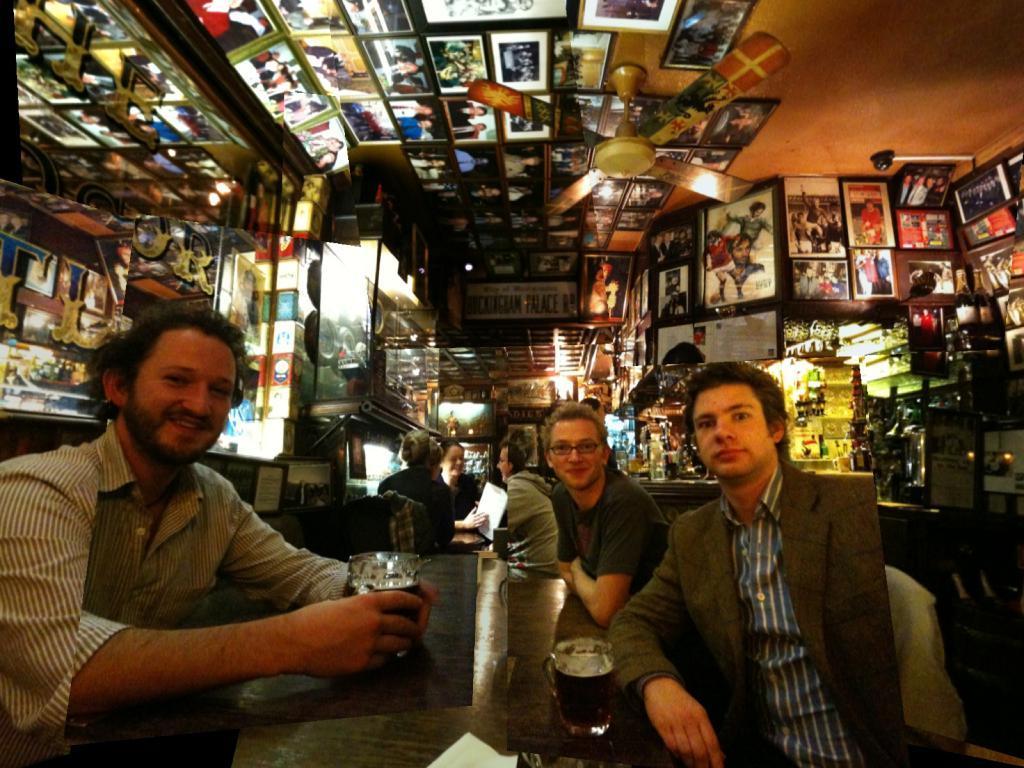How would you summarize this image in a sentence or two? In the center of the image we can see a few people are sitting. Among them, we can see two persons are holding some objects. And we can see one table. On the table, we can see some objects. In the background there is a wall, fan, photo frames, lights and a few other objects. 